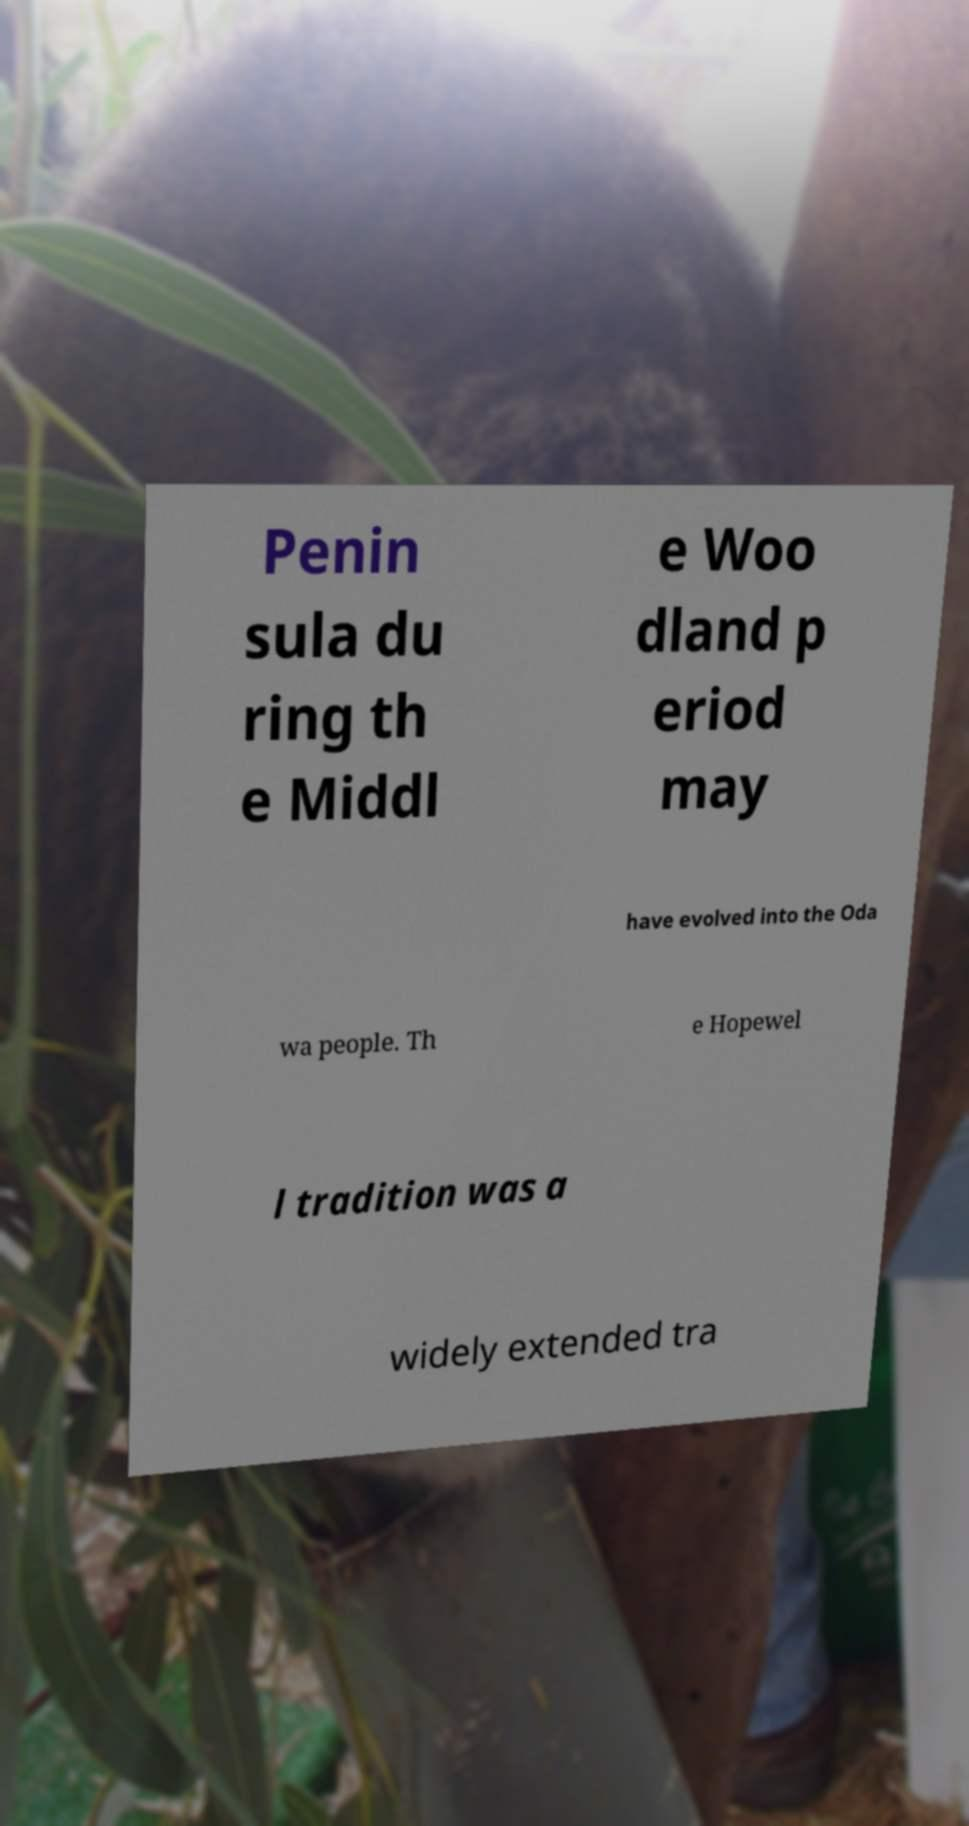Can you read and provide the text displayed in the image?This photo seems to have some interesting text. Can you extract and type it out for me? Penin sula du ring th e Middl e Woo dland p eriod may have evolved into the Oda wa people. Th e Hopewel l tradition was a widely extended tra 